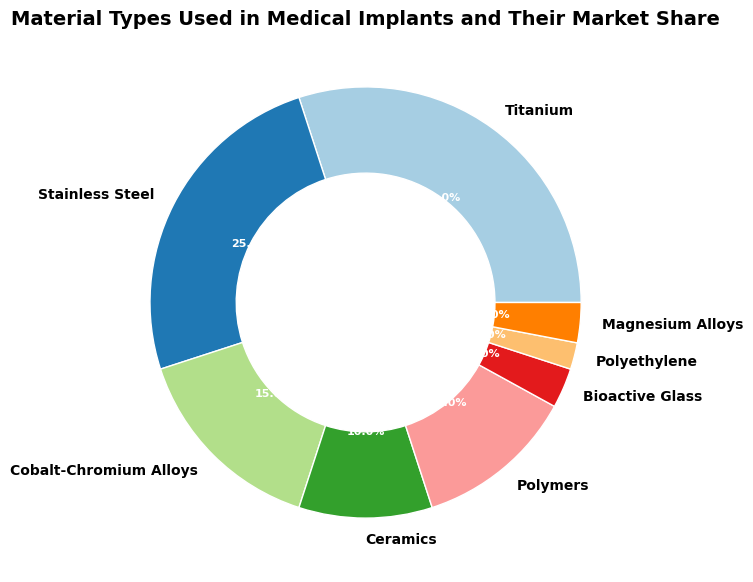What material type has the largest market share in medical implants? Look at the figure and identify the largest slice of the ring chart. The label of this slice corresponds to the material type with the largest market share.
Answer: Titanium Compare the market shares of Titanium and Stainless Steel. Which one is larger and by how much? Titanium has a market share of 30% and Stainless Steel has 25%. Subtract 25% from 30% to find the difference and identify which is larger.
Answer: Titanium by 5% What is the combined market share of Ceramics, Polymers, and Bioactive Glass? Add the market shares of Ceramics (10%), Polymers (12%), and Bioactive Glass (3%). 10% + 12% + 3% = 25%
Answer: 25% Which material type has the smallest market share, and what is this share? Identify the smallest slice in the ring chart. The label adjacent to this slice indicates the material type, and the percentage within the slice shows the market share.
Answer: Polyethylene, 2% Is the market share of Ceramics greater than the sum of Bioactive Glass and Polyethylene? Compare the market share of Ceramics (10%) with the combined market share of Bioactive Glass (3%) and Polyethylene (2%). 3% + 2% = 5% and 10% > 5%
Answer: Yes Which material types have a market share greater than 10%? Review the ring chart and select the material types with slices labeled with shares greater than 10%.
Answer: Titanium, Stainless Steel, Polymers How does the market share of Cobalt-Chromium Alloys compare to that of Magnesium Alloys? Cobalt-Chromium Alloys have a market share of 15% while Magnesium Alloys have a market share of 3%. 15% > 3%
Answer: Cobalt-Chromium Alloys have a larger share What is the difference in market share between the second largest and the smallest material types? The second largest material type is Stainless Steel with 25%, and the smallest is Polyethylene with 2%. Subtract 2% from 25%. 25% - 2% = 23%
Answer: 23% Which segments represent materials with single-digit market shares? Look for slices in the ring chart with percentages labeled in single digits. Identify the material types corresponding to these slices.
Answer: Bioactive Glass, Magnesium Alloys, Polyethylene 